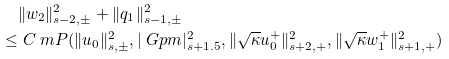<formula> <loc_0><loc_0><loc_500><loc_500>& \| w _ { 2 } \| ^ { 2 } _ { s - 2 , \pm } + \| q _ { 1 } \| ^ { 2 } _ { s - 1 , \pm } \\ \leq & \ C \ m P ( \| u _ { 0 } \| ^ { 2 } _ { s , \pm } , | \ G p m | ^ { 2 } _ { s + 1 . 5 } , \| \sqrt { \kappa } u _ { 0 } ^ { + } \| ^ { 2 } _ { s + 2 , + } , \| \sqrt { \kappa } w _ { 1 } ^ { + } \| ^ { 2 } _ { s + 1 , + } )</formula> 